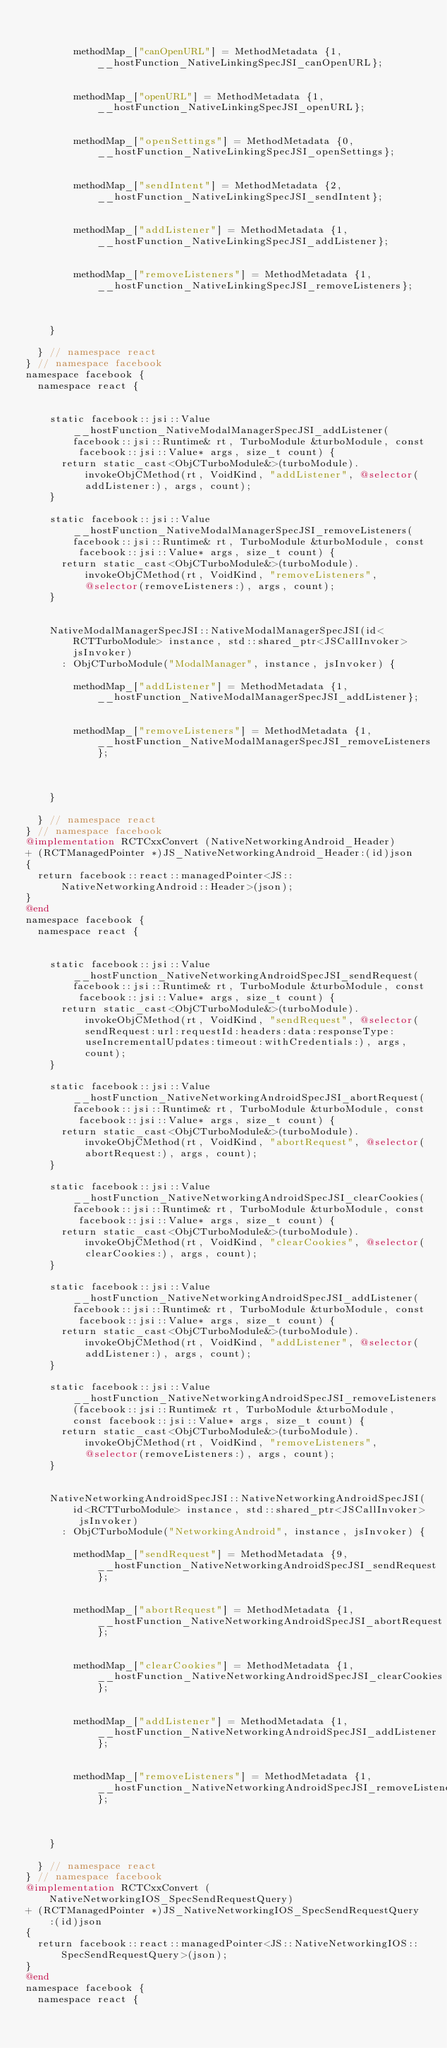Convert code to text. <code><loc_0><loc_0><loc_500><loc_500><_ObjectiveC_>        
        
        methodMap_["canOpenURL"] = MethodMetadata {1, __hostFunction_NativeLinkingSpecJSI_canOpenURL};
        
        
        methodMap_["openURL"] = MethodMetadata {1, __hostFunction_NativeLinkingSpecJSI_openURL};
        
        
        methodMap_["openSettings"] = MethodMetadata {0, __hostFunction_NativeLinkingSpecJSI_openSettings};
        
        
        methodMap_["sendIntent"] = MethodMetadata {2, __hostFunction_NativeLinkingSpecJSI_sendIntent};
        
        
        methodMap_["addListener"] = MethodMetadata {1, __hostFunction_NativeLinkingSpecJSI_addListener};
        
        
        methodMap_["removeListeners"] = MethodMetadata {1, __hostFunction_NativeLinkingSpecJSI_removeListeners};
        
        

    }

  } // namespace react
} // namespace facebook
namespace facebook {
  namespace react {

    
    static facebook::jsi::Value __hostFunction_NativeModalManagerSpecJSI_addListener(facebook::jsi::Runtime& rt, TurboModule &turboModule, const facebook::jsi::Value* args, size_t count) {
      return static_cast<ObjCTurboModule&>(turboModule).invokeObjCMethod(rt, VoidKind, "addListener", @selector(addListener:), args, count);
    }

    static facebook::jsi::Value __hostFunction_NativeModalManagerSpecJSI_removeListeners(facebook::jsi::Runtime& rt, TurboModule &turboModule, const facebook::jsi::Value* args, size_t count) {
      return static_cast<ObjCTurboModule&>(turboModule).invokeObjCMethod(rt, VoidKind, "removeListeners", @selector(removeListeners:), args, count);
    }


    NativeModalManagerSpecJSI::NativeModalManagerSpecJSI(id<RCTTurboModule> instance, std::shared_ptr<JSCallInvoker> jsInvoker)
      : ObjCTurboModule("ModalManager", instance, jsInvoker) {
        
        methodMap_["addListener"] = MethodMetadata {1, __hostFunction_NativeModalManagerSpecJSI_addListener};
        
        
        methodMap_["removeListeners"] = MethodMetadata {1, __hostFunction_NativeModalManagerSpecJSI_removeListeners};
        
        

    }

  } // namespace react
} // namespace facebook
@implementation RCTCxxConvert (NativeNetworkingAndroid_Header)
+ (RCTManagedPointer *)JS_NativeNetworkingAndroid_Header:(id)json
{
  return facebook::react::managedPointer<JS::NativeNetworkingAndroid::Header>(json);
}
@end
namespace facebook {
  namespace react {

    
    static facebook::jsi::Value __hostFunction_NativeNetworkingAndroidSpecJSI_sendRequest(facebook::jsi::Runtime& rt, TurboModule &turboModule, const facebook::jsi::Value* args, size_t count) {
      return static_cast<ObjCTurboModule&>(turboModule).invokeObjCMethod(rt, VoidKind, "sendRequest", @selector(sendRequest:url:requestId:headers:data:responseType:useIncrementalUpdates:timeout:withCredentials:), args, count);
    }

    static facebook::jsi::Value __hostFunction_NativeNetworkingAndroidSpecJSI_abortRequest(facebook::jsi::Runtime& rt, TurboModule &turboModule, const facebook::jsi::Value* args, size_t count) {
      return static_cast<ObjCTurboModule&>(turboModule).invokeObjCMethod(rt, VoidKind, "abortRequest", @selector(abortRequest:), args, count);
    }

    static facebook::jsi::Value __hostFunction_NativeNetworkingAndroidSpecJSI_clearCookies(facebook::jsi::Runtime& rt, TurboModule &turboModule, const facebook::jsi::Value* args, size_t count) {
      return static_cast<ObjCTurboModule&>(turboModule).invokeObjCMethod(rt, VoidKind, "clearCookies", @selector(clearCookies:), args, count);
    }

    static facebook::jsi::Value __hostFunction_NativeNetworkingAndroidSpecJSI_addListener(facebook::jsi::Runtime& rt, TurboModule &turboModule, const facebook::jsi::Value* args, size_t count) {
      return static_cast<ObjCTurboModule&>(turboModule).invokeObjCMethod(rt, VoidKind, "addListener", @selector(addListener:), args, count);
    }

    static facebook::jsi::Value __hostFunction_NativeNetworkingAndroidSpecJSI_removeListeners(facebook::jsi::Runtime& rt, TurboModule &turboModule, const facebook::jsi::Value* args, size_t count) {
      return static_cast<ObjCTurboModule&>(turboModule).invokeObjCMethod(rt, VoidKind, "removeListeners", @selector(removeListeners:), args, count);
    }


    NativeNetworkingAndroidSpecJSI::NativeNetworkingAndroidSpecJSI(id<RCTTurboModule> instance, std::shared_ptr<JSCallInvoker> jsInvoker)
      : ObjCTurboModule("NetworkingAndroid", instance, jsInvoker) {
        
        methodMap_["sendRequest"] = MethodMetadata {9, __hostFunction_NativeNetworkingAndroidSpecJSI_sendRequest};
        
        
        methodMap_["abortRequest"] = MethodMetadata {1, __hostFunction_NativeNetworkingAndroidSpecJSI_abortRequest};
        
        
        methodMap_["clearCookies"] = MethodMetadata {1, __hostFunction_NativeNetworkingAndroidSpecJSI_clearCookies};
        
        
        methodMap_["addListener"] = MethodMetadata {1, __hostFunction_NativeNetworkingAndroidSpecJSI_addListener};
        
        
        methodMap_["removeListeners"] = MethodMetadata {1, __hostFunction_NativeNetworkingAndroidSpecJSI_removeListeners};
        
        

    }

  } // namespace react
} // namespace facebook
@implementation RCTCxxConvert (NativeNetworkingIOS_SpecSendRequestQuery)
+ (RCTManagedPointer *)JS_NativeNetworkingIOS_SpecSendRequestQuery:(id)json
{
  return facebook::react::managedPointer<JS::NativeNetworkingIOS::SpecSendRequestQuery>(json);
}
@end
namespace facebook {
  namespace react {

    </code> 